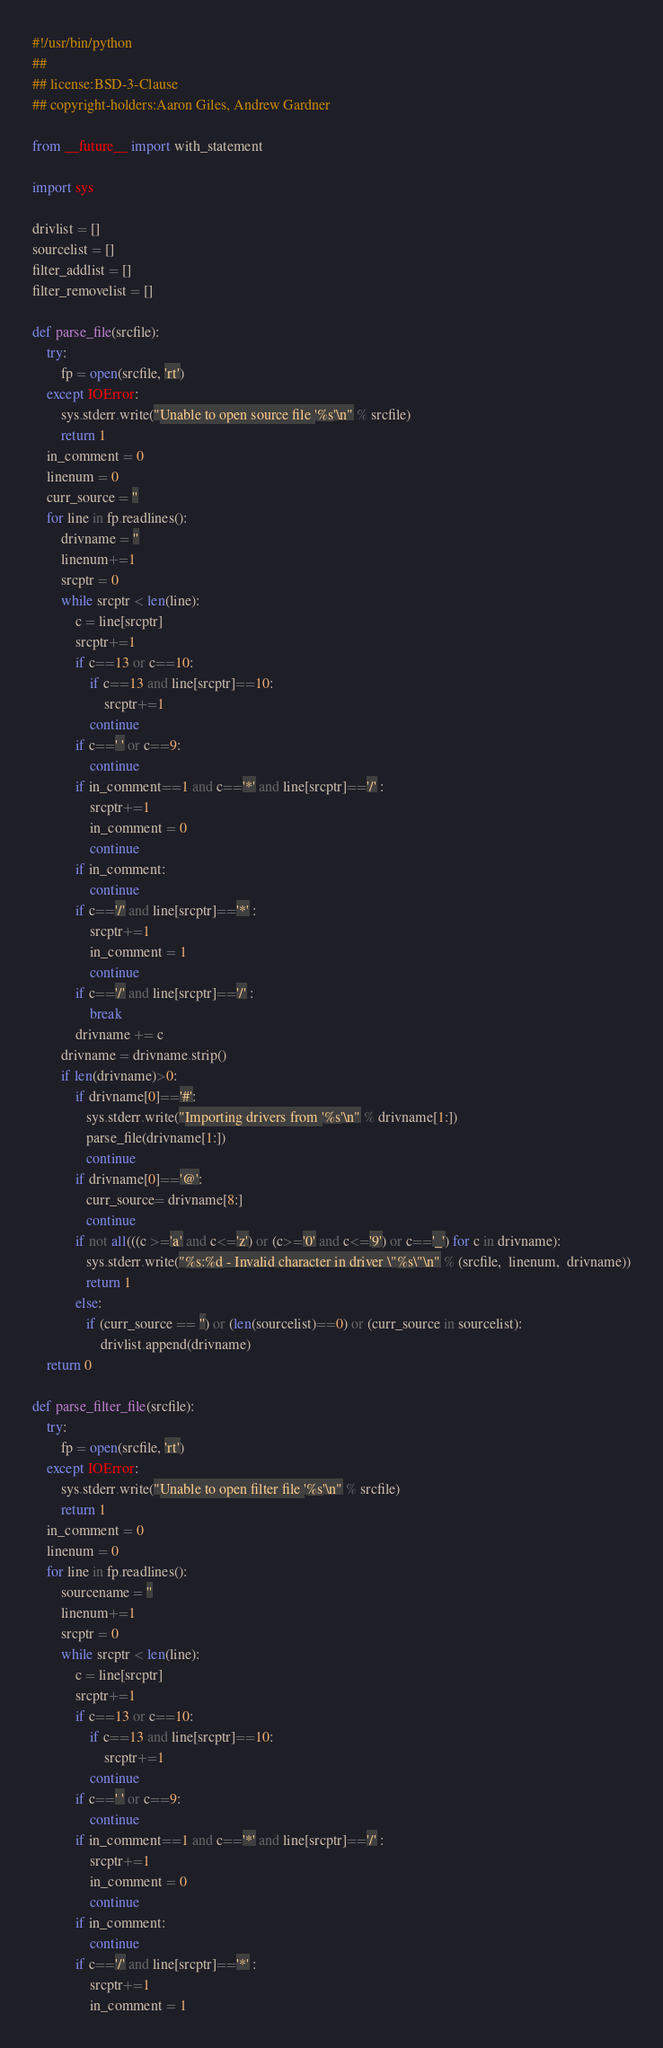Convert code to text. <code><loc_0><loc_0><loc_500><loc_500><_Python_>#!/usr/bin/python
##
## license:BSD-3-Clause
## copyright-holders:Aaron Giles, Andrew Gardner

from __future__ import with_statement

import sys

drivlist = []
sourcelist = []
filter_addlist = []
filter_removelist = []

def parse_file(srcfile):
    try:
        fp = open(srcfile, 'rt')
    except IOError:
        sys.stderr.write("Unable to open source file '%s'\n" % srcfile)
        return 1
    in_comment = 0
    linenum = 0
    curr_source = ''
    for line in fp.readlines():
        drivname = ''
        linenum+=1
        srcptr = 0
        while srcptr < len(line):
            c = line[srcptr]
            srcptr+=1
            if c==13 or c==10:
                if c==13 and line[srcptr]==10:
                    srcptr+=1
                continue
            if c==' ' or c==9:
                continue
            if in_comment==1 and c=='*' and line[srcptr]=='/' :
                srcptr+=1
                in_comment = 0
                continue
            if in_comment:
                continue
            if c=='/' and line[srcptr]=='*' :
                srcptr+=1
                in_comment = 1
                continue
            if c=='/' and line[srcptr]=='/' :
                break
            drivname += c
        drivname = drivname.strip()
        if len(drivname)>0:
            if drivname[0]=='#':
               sys.stderr.write("Importing drivers from '%s'\n" % drivname[1:])
               parse_file(drivname[1:])
               continue
            if drivname[0]=='@':
               curr_source= drivname[8:]
               continue
            if not all(((c >='a' and c<='z') or (c>='0' and c<='9') or c=='_') for c in drivname):
               sys.stderr.write("%s:%d - Invalid character in driver \"%s\"\n" % (srcfile,  linenum,  drivname))
               return 1
            else:
               if (curr_source == '') or (len(sourcelist)==0) or (curr_source in sourcelist):
                   drivlist.append(drivname)
    return 0

def parse_filter_file(srcfile):
    try:
        fp = open(srcfile, 'rt')
    except IOError:
        sys.stderr.write("Unable to open filter file '%s'\n" % srcfile)
        return 1
    in_comment = 0
    linenum = 0
    for line in fp.readlines():
        sourcename = ''
        linenum+=1
        srcptr = 0
        while srcptr < len(line):
            c = line[srcptr]
            srcptr+=1
            if c==13 or c==10:
                if c==13 and line[srcptr]==10:
                    srcptr+=1
                continue
            if c==' ' or c==9:
                continue
            if in_comment==1 and c=='*' and line[srcptr]=='/' :
                srcptr+=1
                in_comment = 0
                continue
            if in_comment:
                continue
            if c=='/' and line[srcptr]=='*' :
                srcptr+=1
                in_comment = 1</code> 